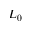<formula> <loc_0><loc_0><loc_500><loc_500>L _ { 0 }</formula> 